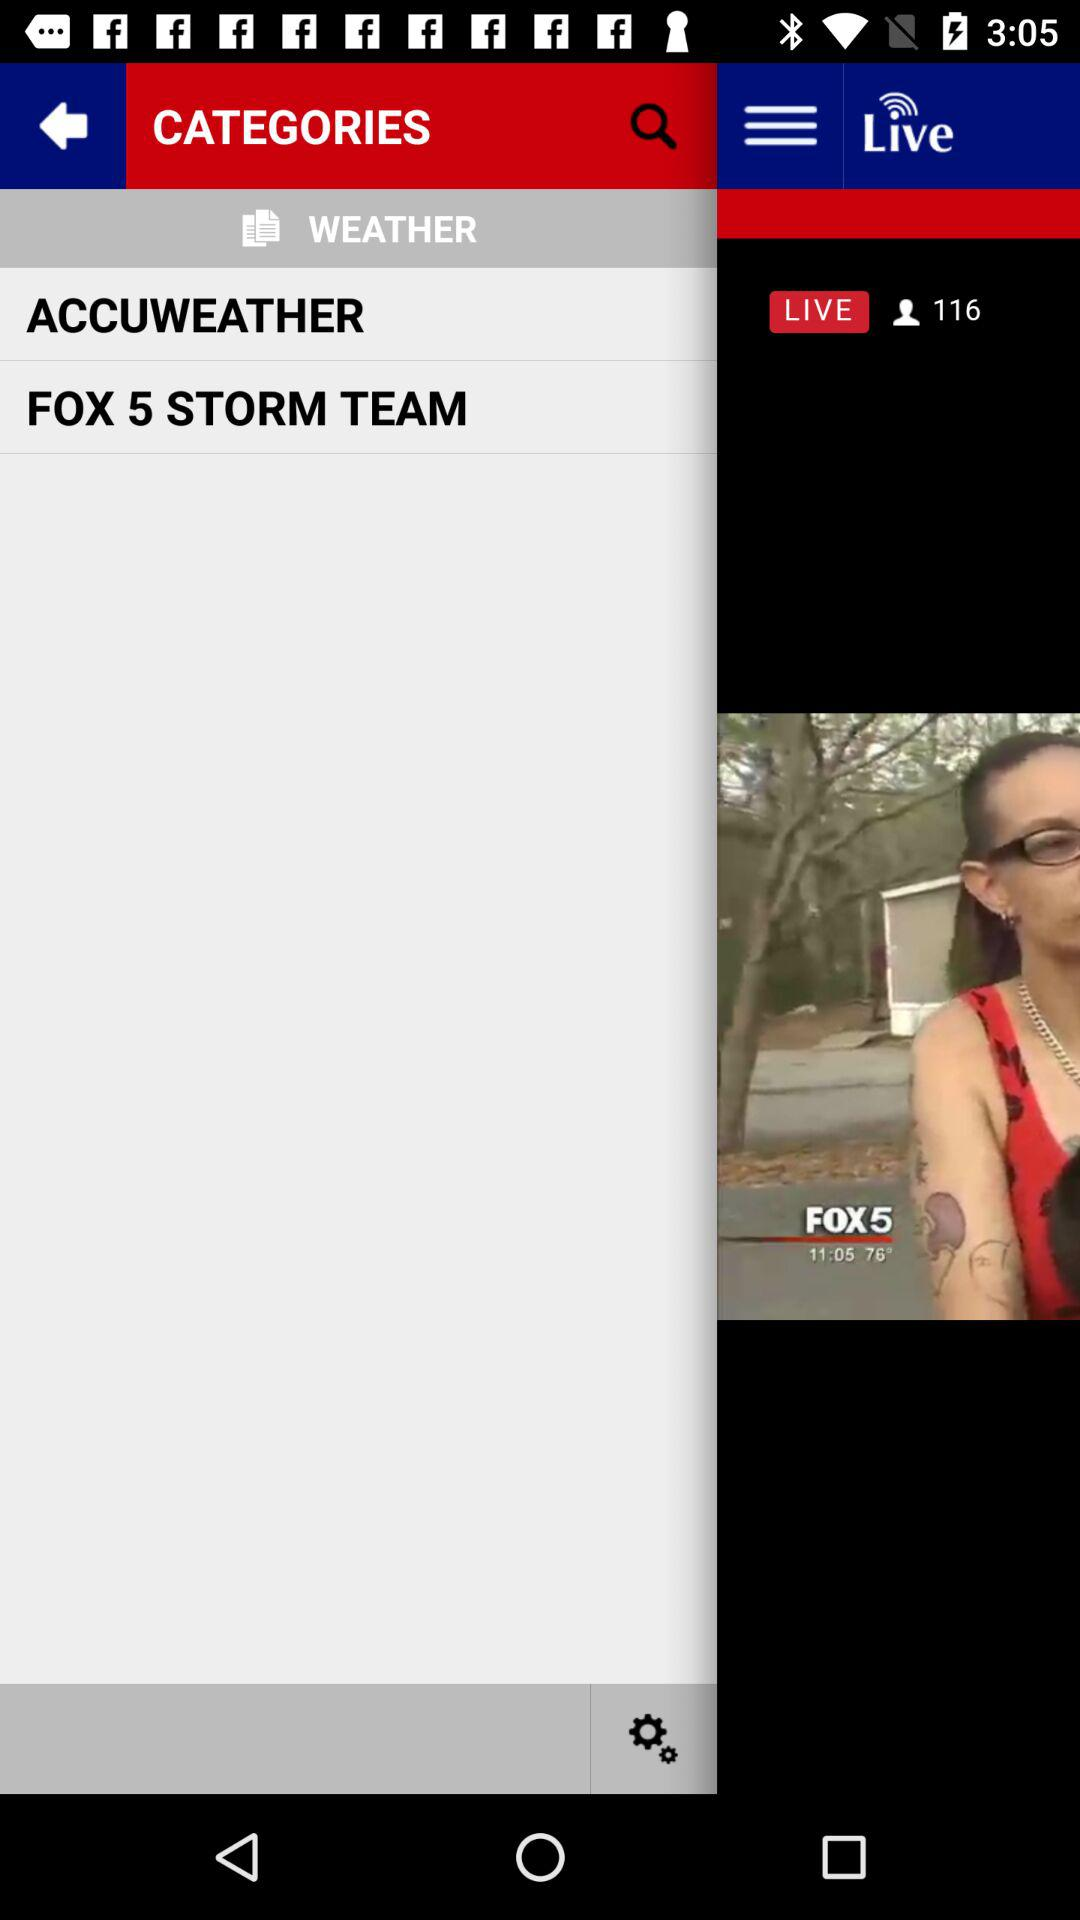What is the temperature? The temperature is 74°. 